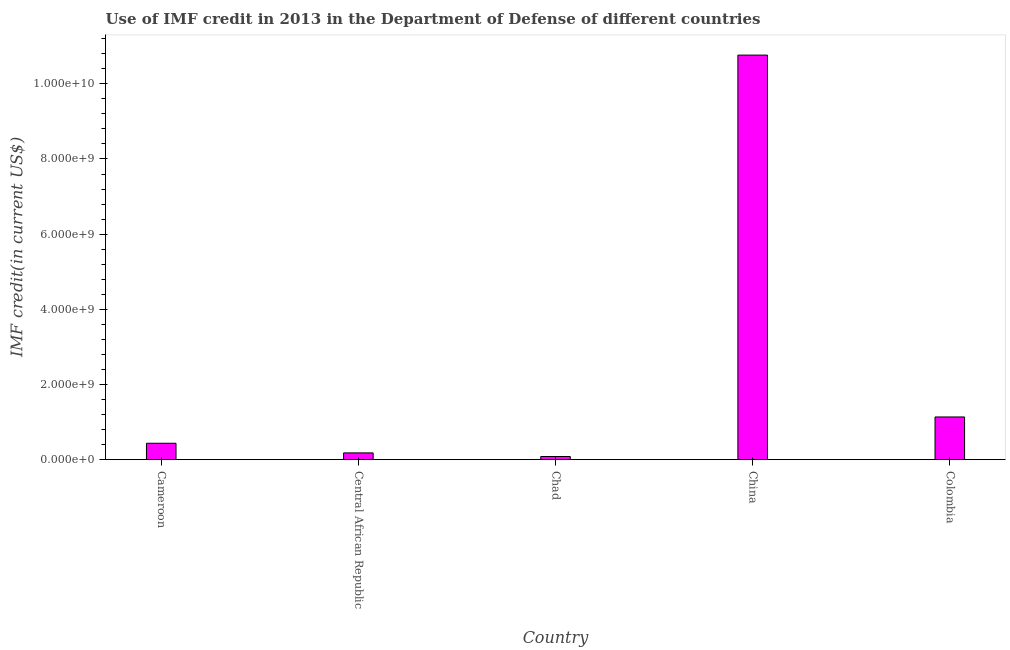Does the graph contain any zero values?
Give a very brief answer. No. What is the title of the graph?
Provide a succinct answer. Use of IMF credit in 2013 in the Department of Defense of different countries. What is the label or title of the Y-axis?
Provide a succinct answer. IMF credit(in current US$). What is the use of imf credit in dod in Colombia?
Make the answer very short. 1.14e+09. Across all countries, what is the maximum use of imf credit in dod?
Offer a terse response. 1.08e+1. Across all countries, what is the minimum use of imf credit in dod?
Your answer should be very brief. 8.45e+07. In which country was the use of imf credit in dod minimum?
Make the answer very short. Chad. What is the sum of the use of imf credit in dod?
Provide a succinct answer. 1.26e+1. What is the difference between the use of imf credit in dod in Cameroon and Chad?
Ensure brevity in your answer.  3.53e+08. What is the average use of imf credit in dod per country?
Your answer should be compact. 2.52e+09. What is the median use of imf credit in dod?
Make the answer very short. 4.37e+08. In how many countries, is the use of imf credit in dod greater than 4000000000 US$?
Your answer should be compact. 1. What is the ratio of the use of imf credit in dod in China to that in Colombia?
Give a very brief answer. 9.47. Is the use of imf credit in dod in Cameroon less than that in China?
Offer a terse response. Yes. What is the difference between the highest and the second highest use of imf credit in dod?
Give a very brief answer. 9.63e+09. Is the sum of the use of imf credit in dod in Central African Republic and Chad greater than the maximum use of imf credit in dod across all countries?
Offer a very short reply. No. What is the difference between the highest and the lowest use of imf credit in dod?
Ensure brevity in your answer.  1.07e+1. In how many countries, is the use of imf credit in dod greater than the average use of imf credit in dod taken over all countries?
Keep it short and to the point. 1. How many bars are there?
Ensure brevity in your answer.  5. What is the difference between two consecutive major ticks on the Y-axis?
Your answer should be compact. 2.00e+09. Are the values on the major ticks of Y-axis written in scientific E-notation?
Your answer should be compact. Yes. What is the IMF credit(in current US$) in Cameroon?
Make the answer very short. 4.37e+08. What is the IMF credit(in current US$) in Central African Republic?
Give a very brief answer. 1.81e+08. What is the IMF credit(in current US$) in Chad?
Offer a very short reply. 8.45e+07. What is the IMF credit(in current US$) of China?
Give a very brief answer. 1.08e+1. What is the IMF credit(in current US$) of Colombia?
Your response must be concise. 1.14e+09. What is the difference between the IMF credit(in current US$) in Cameroon and Central African Republic?
Provide a succinct answer. 2.56e+08. What is the difference between the IMF credit(in current US$) in Cameroon and Chad?
Ensure brevity in your answer.  3.53e+08. What is the difference between the IMF credit(in current US$) in Cameroon and China?
Your response must be concise. -1.03e+1. What is the difference between the IMF credit(in current US$) in Cameroon and Colombia?
Offer a terse response. -7.00e+08. What is the difference between the IMF credit(in current US$) in Central African Republic and Chad?
Provide a succinct answer. 9.65e+07. What is the difference between the IMF credit(in current US$) in Central African Republic and China?
Provide a succinct answer. -1.06e+1. What is the difference between the IMF credit(in current US$) in Central African Republic and Colombia?
Your response must be concise. -9.56e+08. What is the difference between the IMF credit(in current US$) in Chad and China?
Give a very brief answer. -1.07e+1. What is the difference between the IMF credit(in current US$) in Chad and Colombia?
Give a very brief answer. -1.05e+09. What is the difference between the IMF credit(in current US$) in China and Colombia?
Ensure brevity in your answer.  9.63e+09. What is the ratio of the IMF credit(in current US$) in Cameroon to that in Central African Republic?
Offer a very short reply. 2.42. What is the ratio of the IMF credit(in current US$) in Cameroon to that in Chad?
Provide a succinct answer. 5.17. What is the ratio of the IMF credit(in current US$) in Cameroon to that in China?
Make the answer very short. 0.04. What is the ratio of the IMF credit(in current US$) in Cameroon to that in Colombia?
Ensure brevity in your answer.  0.39. What is the ratio of the IMF credit(in current US$) in Central African Republic to that in Chad?
Provide a succinct answer. 2.14. What is the ratio of the IMF credit(in current US$) in Central African Republic to that in China?
Your answer should be compact. 0.02. What is the ratio of the IMF credit(in current US$) in Central African Republic to that in Colombia?
Your response must be concise. 0.16. What is the ratio of the IMF credit(in current US$) in Chad to that in China?
Make the answer very short. 0.01. What is the ratio of the IMF credit(in current US$) in Chad to that in Colombia?
Your answer should be very brief. 0.07. What is the ratio of the IMF credit(in current US$) in China to that in Colombia?
Your answer should be compact. 9.47. 